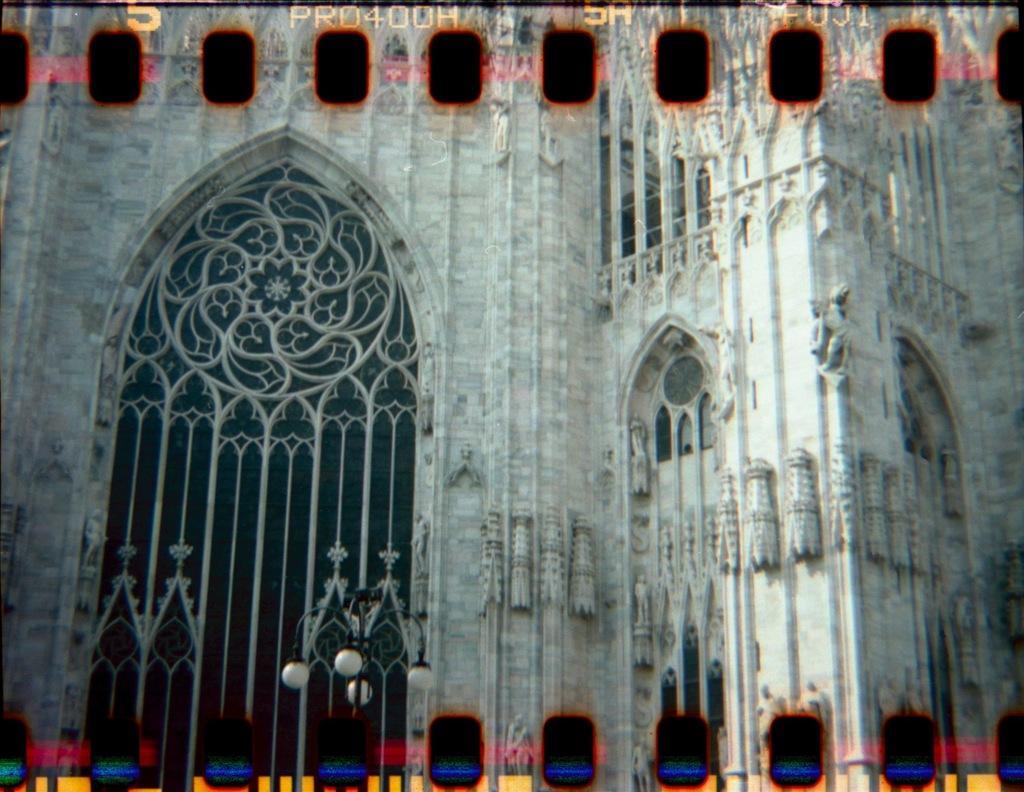How would you summarize this image in a sentence or two? In this picture we can see a building. On the left we can see a door. Here we can see street light. On the top we can see watermark. 